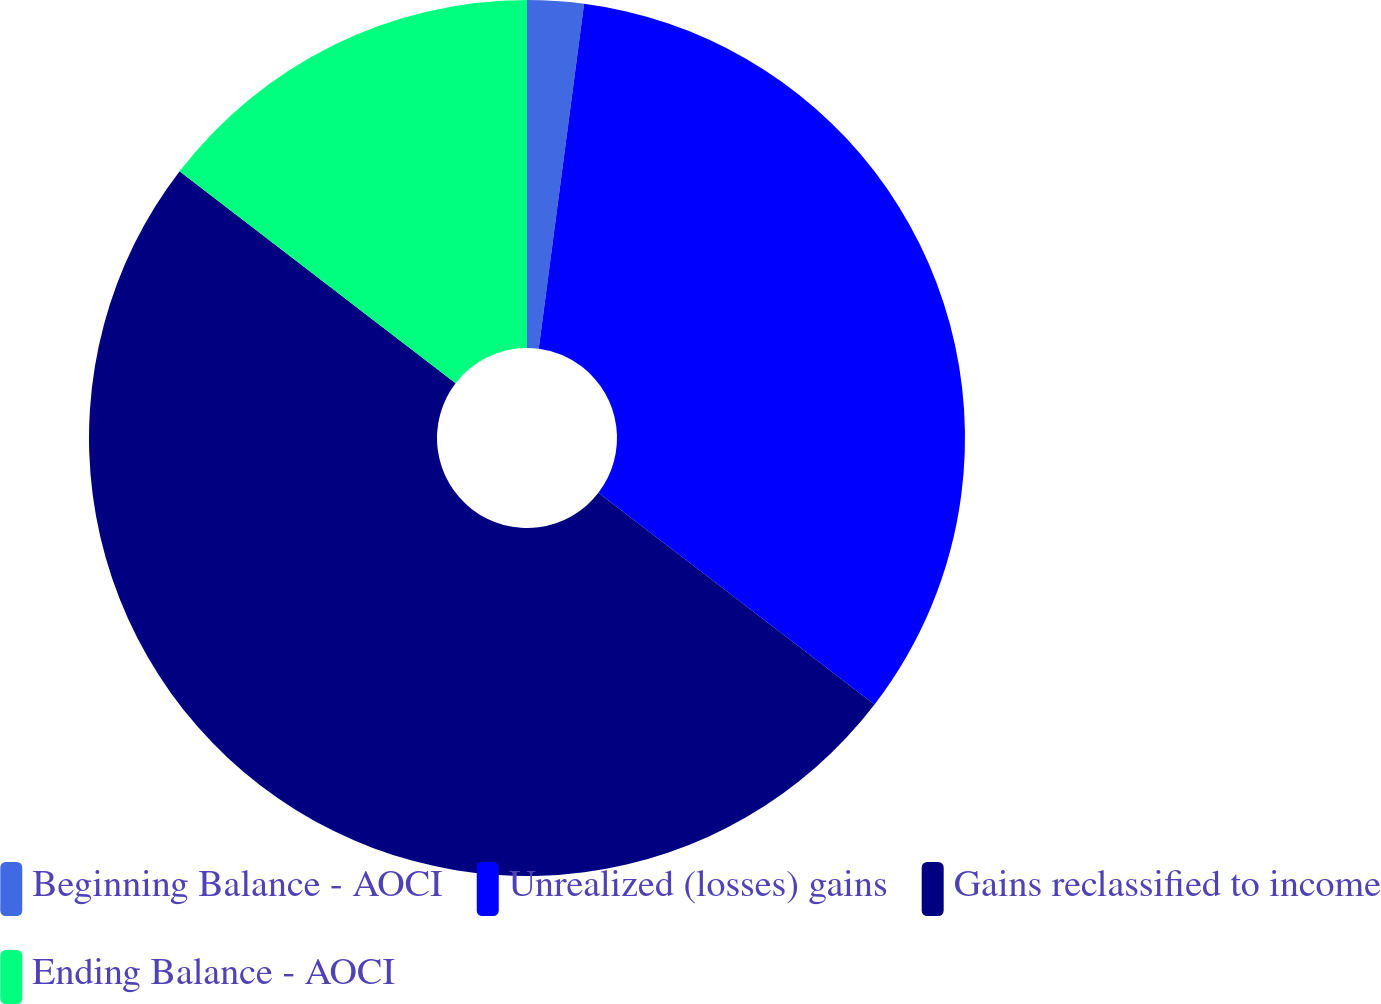<chart> <loc_0><loc_0><loc_500><loc_500><pie_chart><fcel>Beginning Balance - AOCI<fcel>Unrealized (losses) gains<fcel>Gains reclassified to income<fcel>Ending Balance - AOCI<nl><fcel>2.08%<fcel>33.33%<fcel>50.0%<fcel>14.58%<nl></chart> 